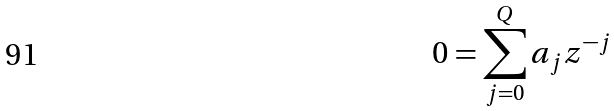Convert formula to latex. <formula><loc_0><loc_0><loc_500><loc_500>0 = \sum _ { j = 0 } ^ { Q } a _ { j } z ^ { - j }</formula> 